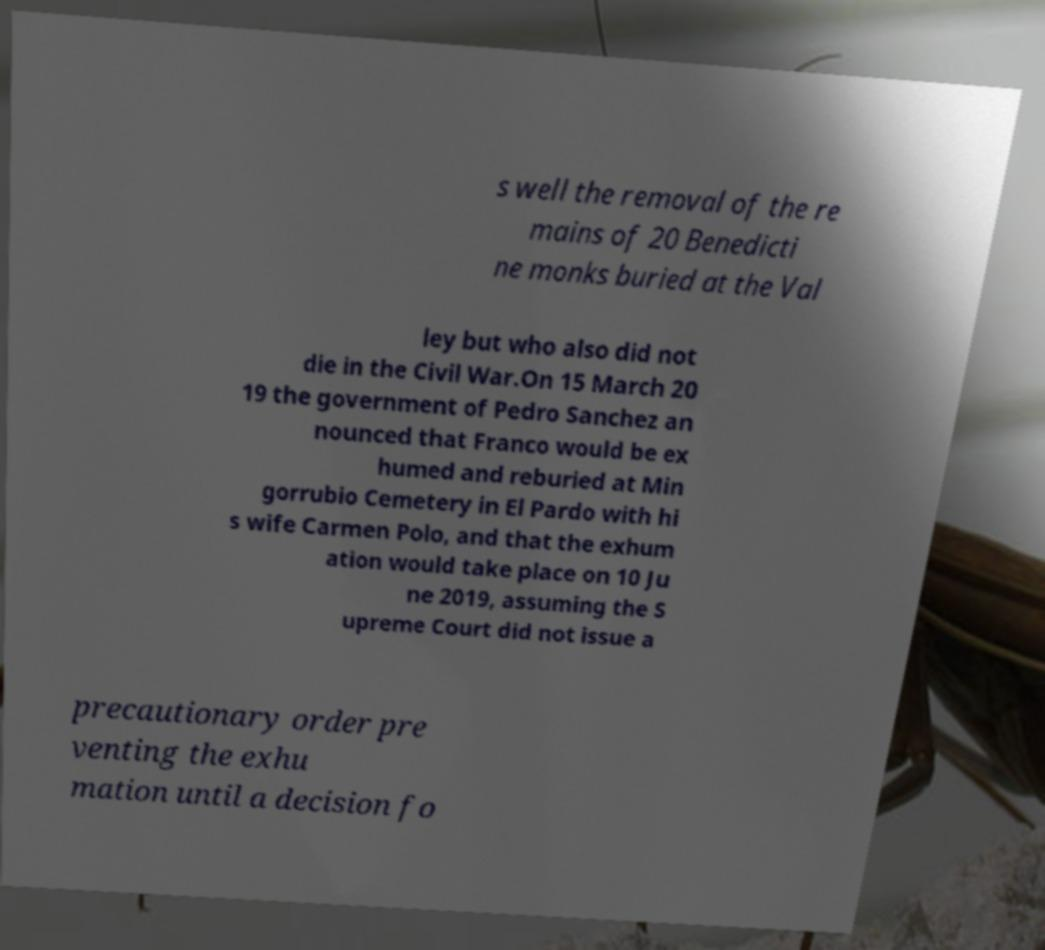Could you assist in decoding the text presented in this image and type it out clearly? s well the removal of the re mains of 20 Benedicti ne monks buried at the Val ley but who also did not die in the Civil War.On 15 March 20 19 the government of Pedro Sanchez an nounced that Franco would be ex humed and reburied at Min gorrubio Cemetery in El Pardo with hi s wife Carmen Polo, and that the exhum ation would take place on 10 Ju ne 2019, assuming the S upreme Court did not issue a precautionary order pre venting the exhu mation until a decision fo 